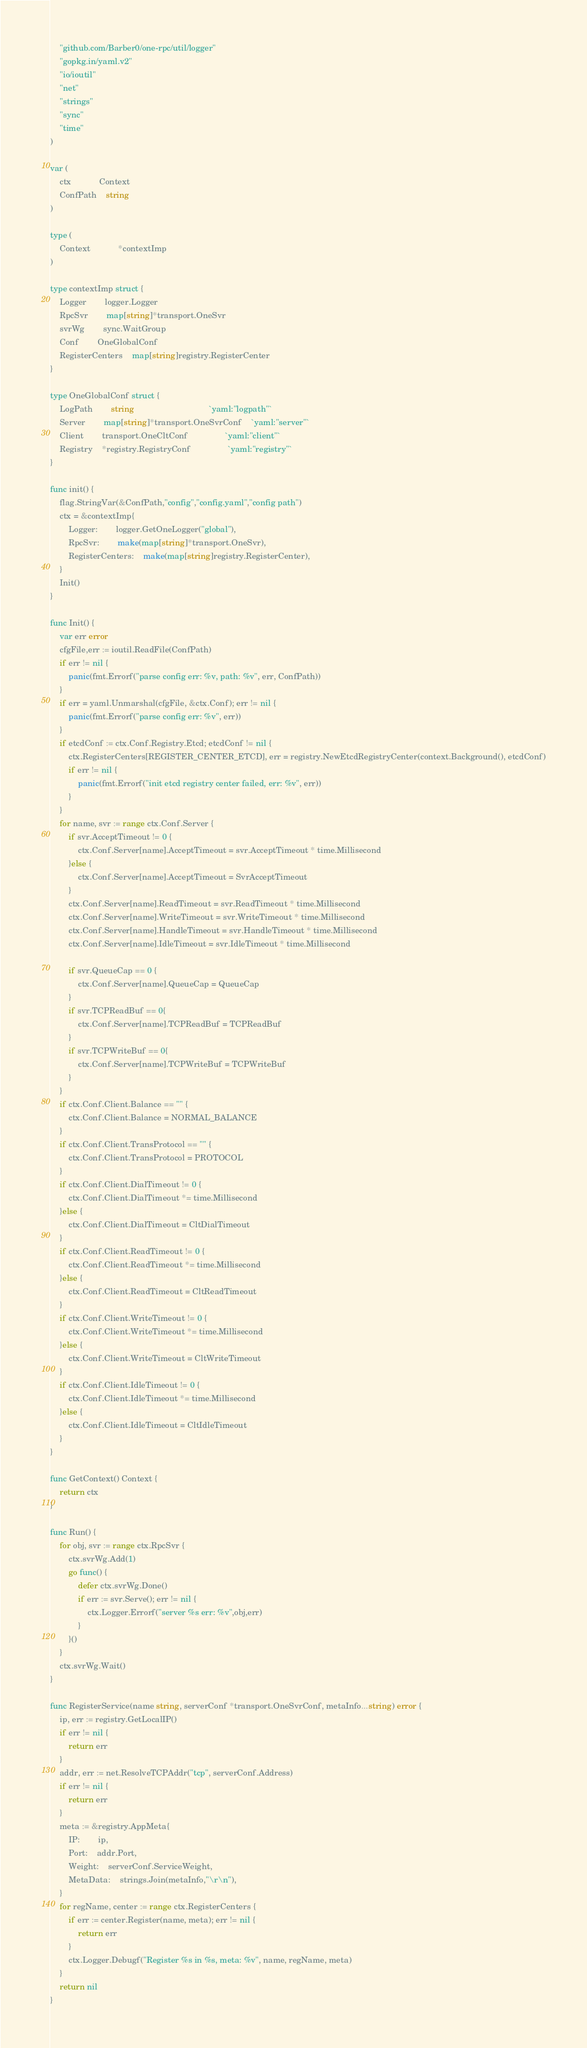Convert code to text. <code><loc_0><loc_0><loc_500><loc_500><_Go_>	"github.com/Barber0/one-rpc/util/logger"
	"gopkg.in/yaml.v2"
	"io/ioutil"
	"net"
	"strings"
	"sync"
	"time"
)

var (
	ctx			Context
	ConfPath	string
)

type (
	Context 			*contextImp
)

type contextImp struct {
	Logger		logger.Logger
	RpcSvr		map[string]*transport.OneSvr
	svrWg		sync.WaitGroup
	Conf		OneGlobalConf
	RegisterCenters	map[string]registry.RegisterCenter
}

type OneGlobalConf struct {
	LogPath		string								`yaml:"logpath"`
	Server		map[string]*transport.OneSvrConf	`yaml:"server"`
	Client		transport.OneCltConf				`yaml:"client"`
	Registry	*registry.RegistryConf				`yaml:"registry"`
}

func init() {
	flag.StringVar(&ConfPath,"config","config.yaml","config path")
	ctx = &contextImp{
		Logger:		logger.GetOneLogger("global"),
		RpcSvr:		make(map[string]*transport.OneSvr),
		RegisterCenters:	make(map[string]registry.RegisterCenter),
	}
	Init()
}

func Init() {
	var err error
	cfgFile,err := ioutil.ReadFile(ConfPath)
	if err != nil {
		panic(fmt.Errorf("parse config err: %v, path: %v", err, ConfPath))
	}
	if err = yaml.Unmarshal(cfgFile, &ctx.Conf); err != nil {
		panic(fmt.Errorf("parse config err: %v", err))
	}
	if etcdConf := ctx.Conf.Registry.Etcd; etcdConf != nil {
		ctx.RegisterCenters[REGISTER_CENTER_ETCD], err = registry.NewEtcdRegistryCenter(context.Background(), etcdConf)
		if err != nil {
			panic(fmt.Errorf("init etcd registry center failed, err: %v", err))
		}
	}
	for name, svr := range ctx.Conf.Server {
		if svr.AcceptTimeout != 0 {
			ctx.Conf.Server[name].AcceptTimeout = svr.AcceptTimeout * time.Millisecond
		}else {
			ctx.Conf.Server[name].AcceptTimeout = SvrAcceptTimeout
		}
		ctx.Conf.Server[name].ReadTimeout = svr.ReadTimeout * time.Millisecond
		ctx.Conf.Server[name].WriteTimeout = svr.WriteTimeout * time.Millisecond
		ctx.Conf.Server[name].HandleTimeout = svr.HandleTimeout * time.Millisecond
		ctx.Conf.Server[name].IdleTimeout = svr.IdleTimeout * time.Millisecond

		if svr.QueueCap == 0 {
			ctx.Conf.Server[name].QueueCap = QueueCap
		}
		if svr.TCPReadBuf == 0{
			ctx.Conf.Server[name].TCPReadBuf = TCPReadBuf
		}
		if svr.TCPWriteBuf == 0{
			ctx.Conf.Server[name].TCPWriteBuf = TCPWriteBuf
		}
	}
	if ctx.Conf.Client.Balance == "" {
		ctx.Conf.Client.Balance = NORMAL_BALANCE
	}
	if ctx.Conf.Client.TransProtocol == "" {
		ctx.Conf.Client.TransProtocol = PROTOCOL
	}
	if ctx.Conf.Client.DialTimeout != 0 {
		ctx.Conf.Client.DialTimeout *= time.Millisecond
	}else {
		ctx.Conf.Client.DialTimeout = CltDialTimeout
	}
	if ctx.Conf.Client.ReadTimeout != 0 {
		ctx.Conf.Client.ReadTimeout *= time.Millisecond
	}else {
		ctx.Conf.Client.ReadTimeout = CltReadTimeout
	}
	if ctx.Conf.Client.WriteTimeout != 0 {
		ctx.Conf.Client.WriteTimeout *= time.Millisecond
	}else {
		ctx.Conf.Client.WriteTimeout = CltWriteTimeout
	}
	if ctx.Conf.Client.IdleTimeout != 0 {
		ctx.Conf.Client.IdleTimeout *= time.Millisecond
	}else {
		ctx.Conf.Client.IdleTimeout = CltIdleTimeout
	}
}

func GetContext() Context {
	return ctx
}

func Run() {
	for obj, svr := range ctx.RpcSvr {
		ctx.svrWg.Add(1)
		go func() {
			defer ctx.svrWg.Done()
			if err := svr.Serve(); err != nil {
				ctx.Logger.Errorf("server %s err: %v",obj,err)
			}
		}()
	}
	ctx.svrWg.Wait()
}

func RegisterService(name string, serverConf *transport.OneSvrConf, metaInfo...string) error {
	ip, err := registry.GetLocalIP()
	if err != nil {
		return err
	}
	addr, err := net.ResolveTCPAddr("tcp", serverConf.Address)
	if err != nil {
		return err
	}
	meta := &registry.AppMeta{
		IP:		ip,
		Port:	addr.Port,
		Weight:	serverConf.ServiceWeight,
		MetaData:	strings.Join(metaInfo,"\r\n"),
	}
	for regName, center := range ctx.RegisterCenters {
		if err := center.Register(name, meta); err != nil {
			return err
		}
		ctx.Logger.Debugf("Register %s in %s, meta: %v", name, regName, meta)
	}
	return nil
}</code> 